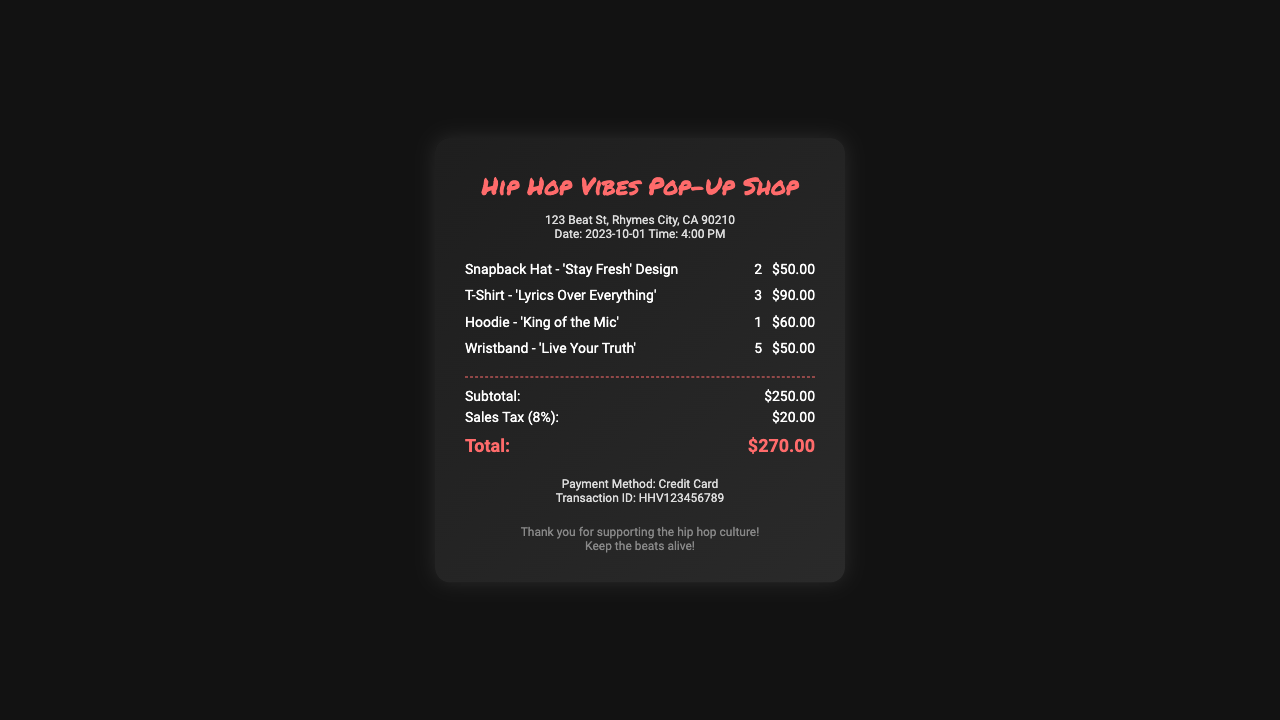What is the name of the shop? The name of the shop is prominently displayed at the top of the receipt.
Answer: Hip Hop Vibes Pop-Up Shop How many T-Shirts were purchased? The quantity of T-Shirts is listed next to the item description in the items section.
Answer: 3 What is the price of the Hoodie? The price of the Hoodie is indicated next to the item in the items section.
Answer: $60.00 What is the total amount spent? The total amount is the final sum indicated in the totals section.
Answer: $270.00 What is the sales tax percentage? The sales tax percentage is mentioned in the breakdown of totals.
Answer: 8% How many items were purchased in total? The total number of items can be calculated by adding the quantities found next to each item.
Answer: 11 What is the payment method? The payment method is stated in the payment information section at the bottom of the receipt.
Answer: Credit Card What is the date of the purchase? The date of the purchase is listed in the store info section of the document.
Answer: 2023-10-01 What is the transaction ID? The transaction ID is provided in the payment info section of the receipt.
Answer: HHV123456789 